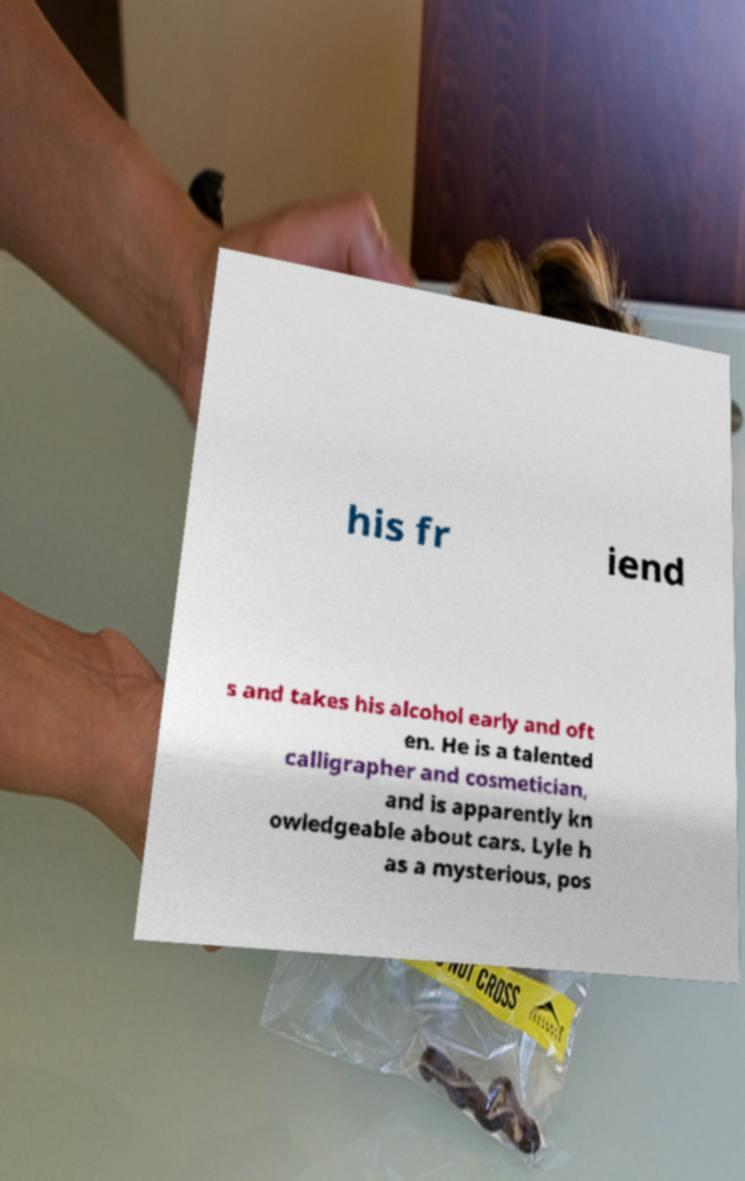Please identify and transcribe the text found in this image. his fr iend s and takes his alcohol early and oft en. He is a talented calligrapher and cosmetician, and is apparently kn owledgeable about cars. Lyle h as a mysterious, pos 